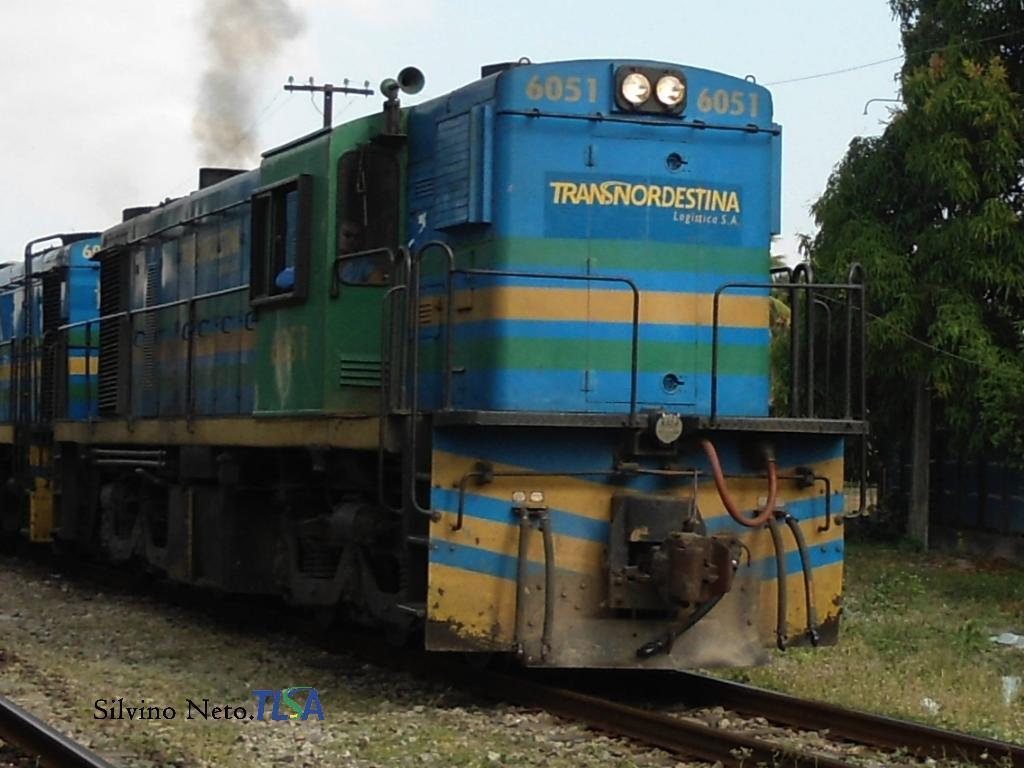Please provide a concise description of this image. In this image there is a train on a track, in the background there are trees and a sky, in the bottom left there is text and a track. 